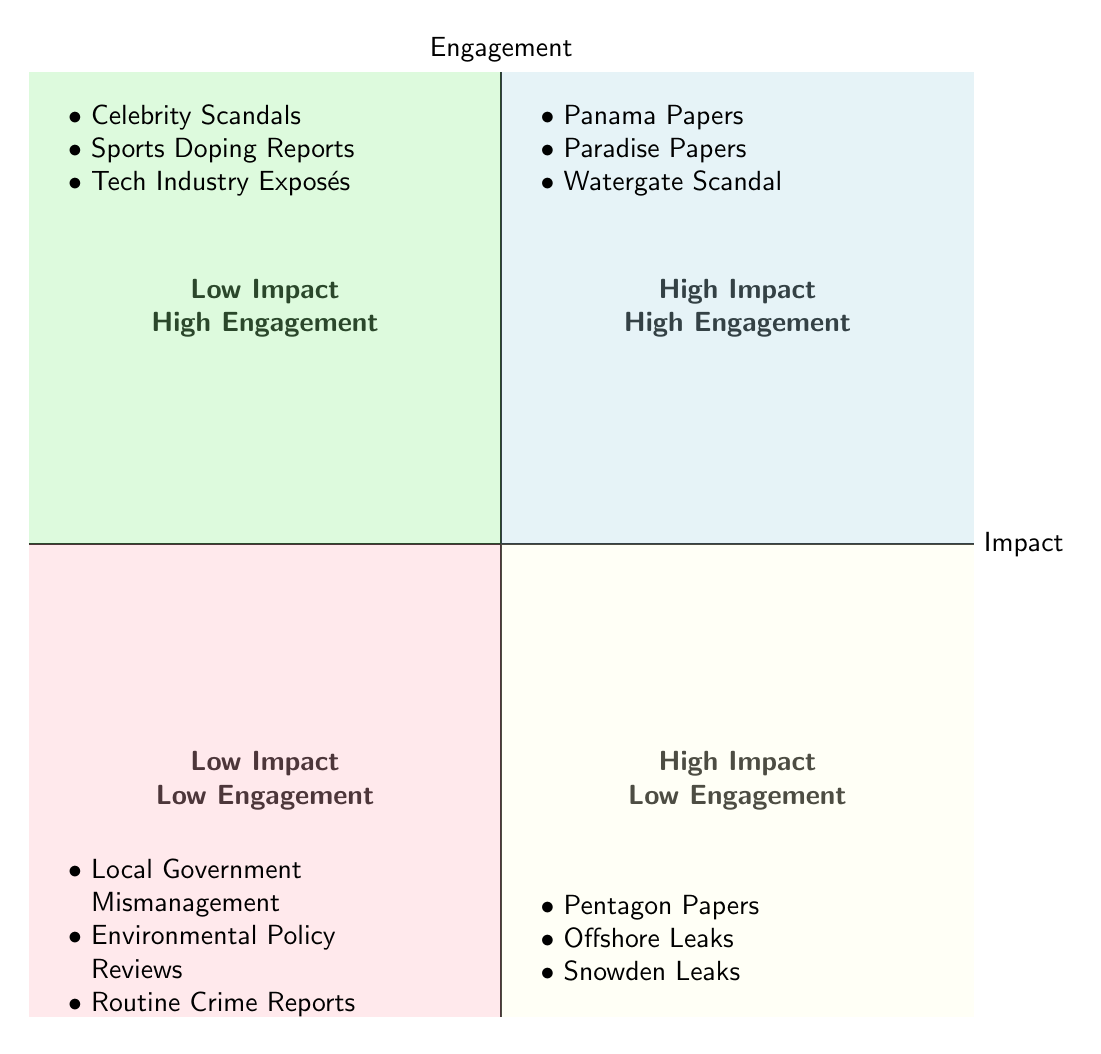What are the titles in the High Impact, High Engagement quadrant? The High Impact, High Engagement quadrant includes Panama Papers, Paradise Papers, and Watergate Scandal, which are all listed in that section of the diagram.
Answer: Panama Papers, Paradise Papers, Watergate Scandal How many titles are in the Low Impact, Low Engagement quadrant? There are three titles listed in the Low Impact, Low Engagement quadrant: Local Government Mismanagement, Environmental Policy Reviews, and Routine Crime Reports.
Answer: 3 Which quadrant has Celebrity Scandals? Celebrity Scandals is listed in the Low Impact, High Engagement quadrant, as indicated in the diagram.
Answer: Low Impact, High Engagement Which is the only quadrant that contains Snowden Leaks? Snowden Leaks is placed in the High Impact, Low Engagement quadrant according to its position in the diagram.
Answer: High Impact, Low Engagement Which quadrant has the most titles? The Low Impact, Low Engagement quadrant contains three titles; therefore, it has the most titles when compared to the other quadrants in the diagram.
Answer: Low Impact, Low Engagement What is the characteristic of stories like Pentagon Papers? Pentagon Papers are characterized as High Impact, Low Engagement stories, as shown in the diagram by their position.
Answer: High Impact, Low Engagement Which two quadrants both feature the term "Engagement"? The quadrants that feature the term "Engagement" are High Engagement and Low Engagement. This is evident by their labeling on the vertical axis of the diagram.
Answer: High Engagement and Low Engagement How do High Impact stories differ in Engagement? High Impact stories can either be High Engagement (like Panama Papers and Watergate Scandal) or Low Engagement (like Pentagon Papers), showing a variability in readership engagement among high-impact stories.
Answer: High Engagement, Low Engagement 